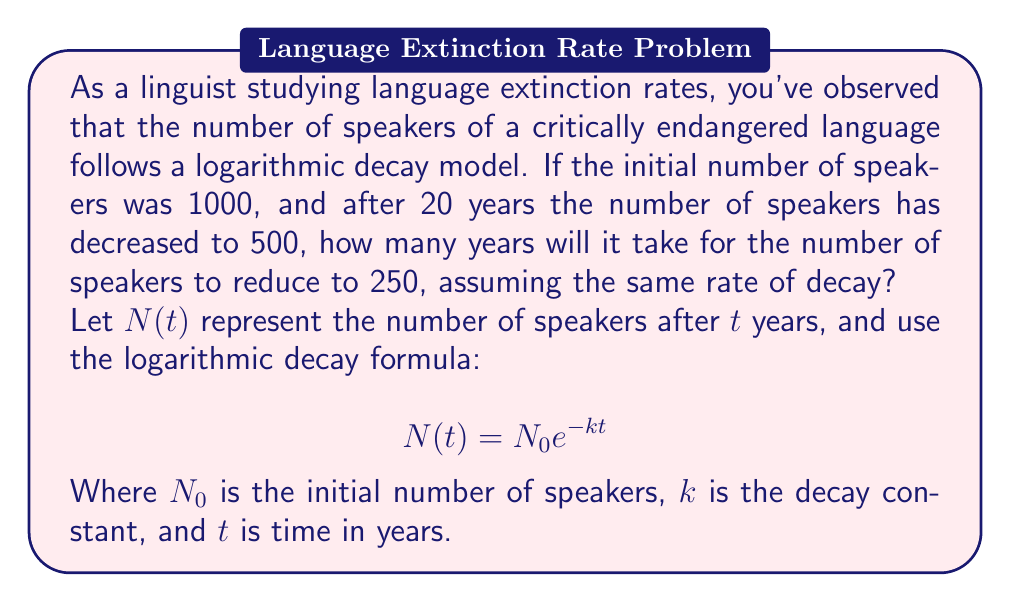Help me with this question. To solve this problem, we'll follow these steps:

1) First, we need to find the decay constant $k$ using the given information:
   $N_0 = 1000$, $N(20) = 500$, $t = 20$

2) Substitute these into the logarithmic decay formula:
   $500 = 1000 e^{-k(20)}$

3) Simplify and solve for $k$:
   $\frac{1}{2} = e^{-20k}$
   $\ln(\frac{1}{2}) = -20k$
   $k = \frac{\ln(2)}{20} \approx 0.0347$

4) Now that we have $k$, we can find $t$ when $N(t) = 250$:
   $250 = 1000 e^{-0.0347t}$

5) Solve for $t$:
   $\frac{1}{4} = e^{-0.0347t}$
   $\ln(\frac{1}{4}) = -0.0347t$
   $t = \frac{\ln(4)}{0.0347} \approx 40$

Therefore, it will take approximately 40 years for the number of speakers to reduce to 250.
Answer: 40 years 